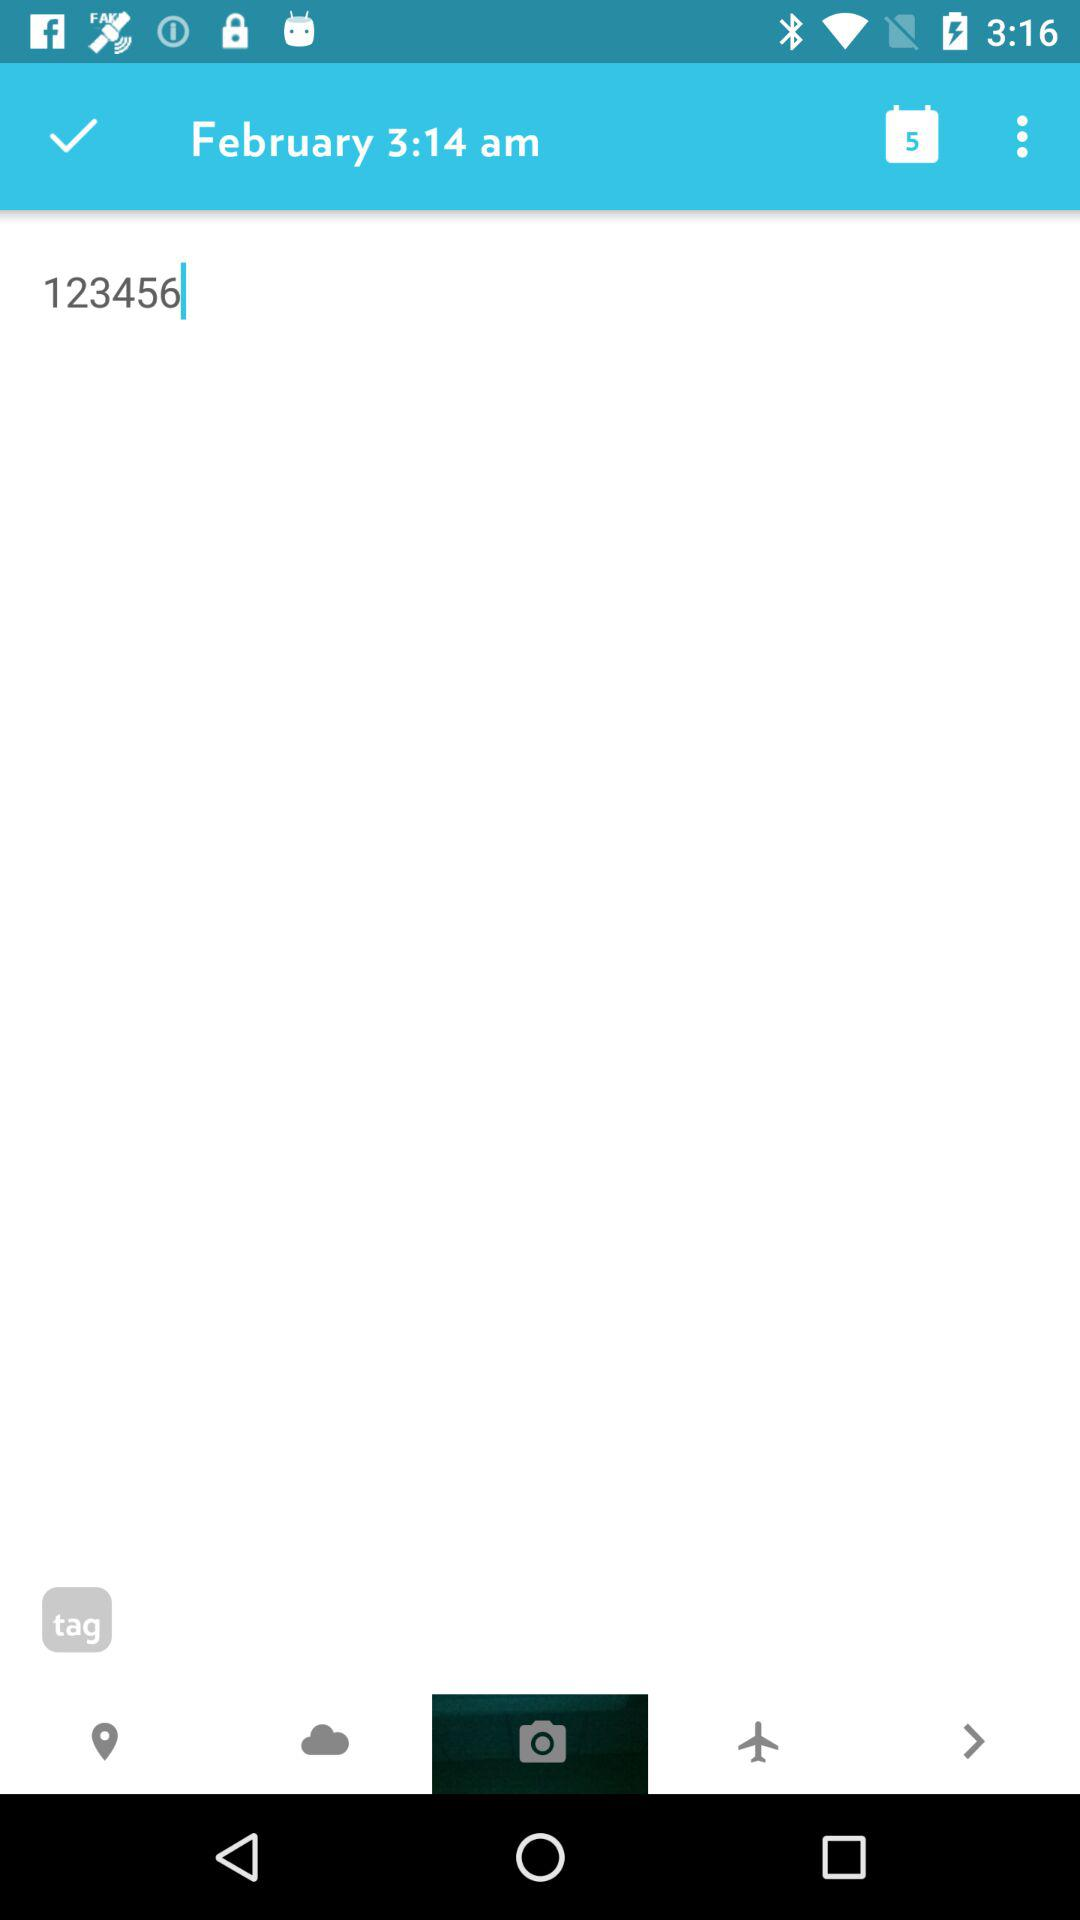At what time was the note created? The note was created at 3:14 a.m. 